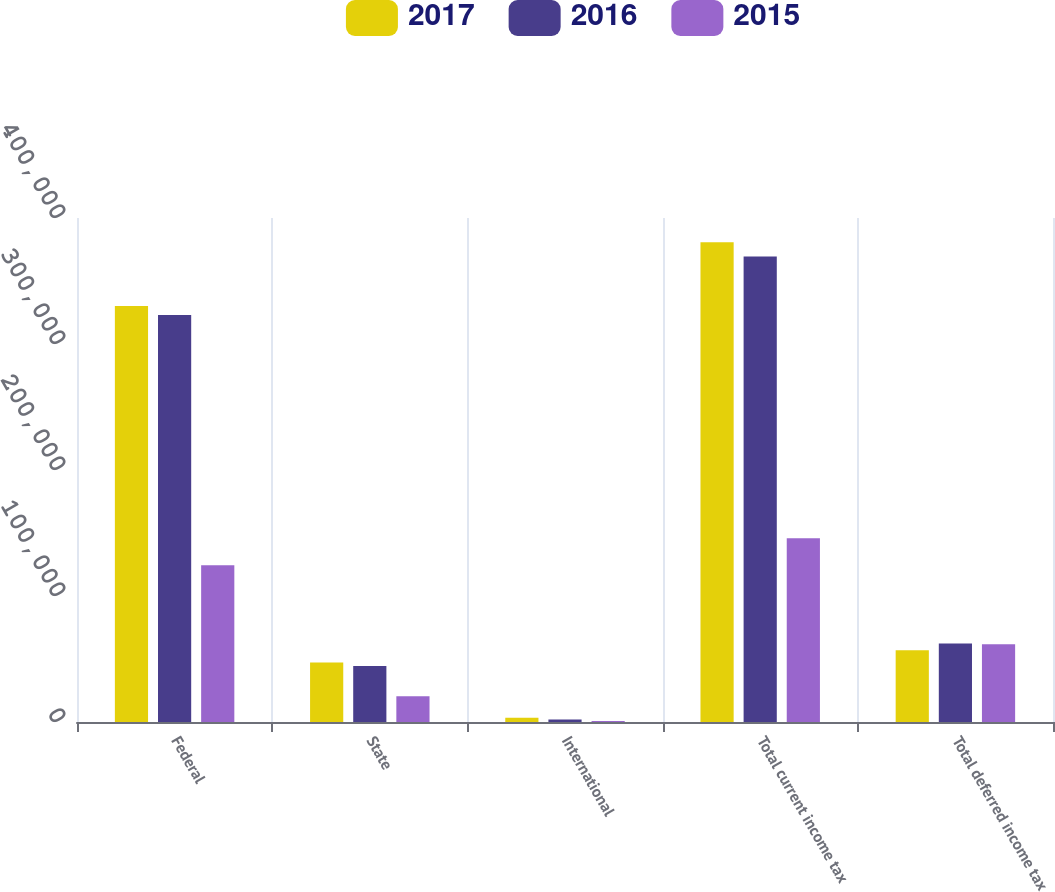Convert chart. <chart><loc_0><loc_0><loc_500><loc_500><stacked_bar_chart><ecel><fcel>Federal<fcel>State<fcel>International<fcel>Total current income tax<fcel>Total deferred income tax<nl><fcel>2017<fcel>330191<fcel>47228<fcel>3422<fcel>380841<fcel>56982<nl><fcel>2016<fcel>322940<fcel>44525<fcel>1928<fcel>369393<fcel>62368<nl><fcel>2015<fcel>124503<fcel>20442<fcel>856<fcel>145801<fcel>61709<nl></chart> 